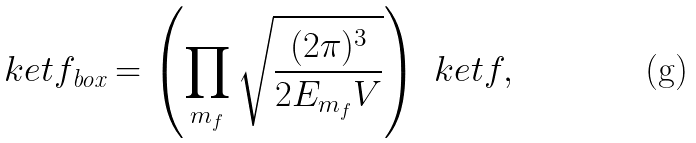Convert formula to latex. <formula><loc_0><loc_0><loc_500><loc_500>\ k e t { f } _ { \text {box} } = \left ( \prod _ { m _ { f } } \sqrt { \frac { ( 2 \pi ) ^ { 3 } } { 2 E _ { m _ { f } } V } } \right ) \ k e t { f } ,</formula> 